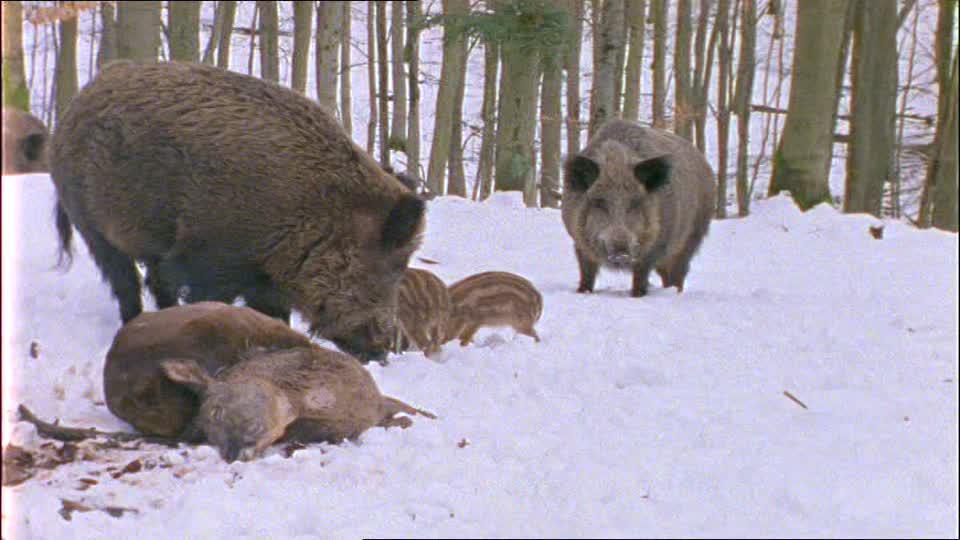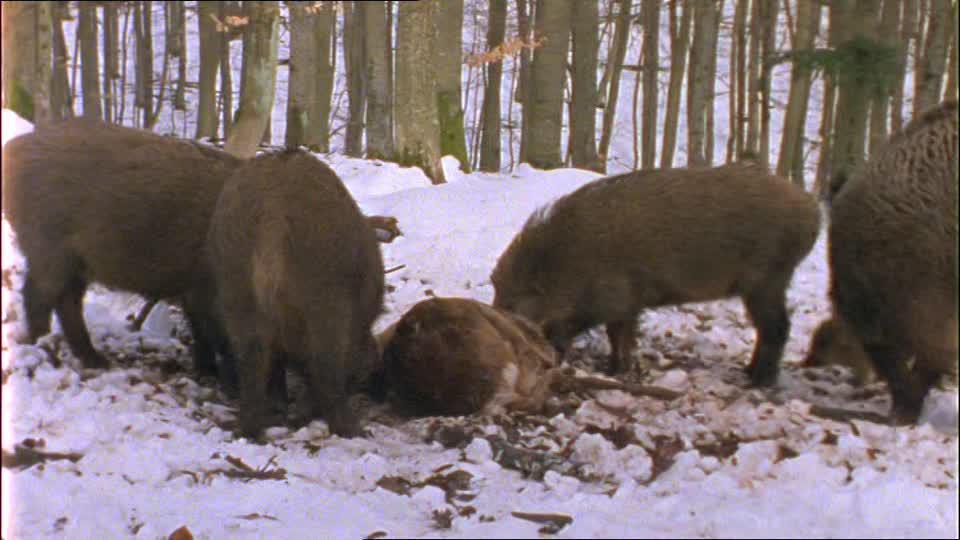The first image is the image on the left, the second image is the image on the right. Considering the images on both sides, is "Some of the pigs are standing in snow." valid? Answer yes or no. Yes. The first image is the image on the left, the second image is the image on the right. Assess this claim about the two images: "One image shows several striped wild boar piglets sharing a meaty meal with their elders.". Correct or not? Answer yes or no. Yes. 